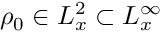Convert formula to latex. <formula><loc_0><loc_0><loc_500><loc_500>\rho _ { 0 } \in L _ { x } ^ { 2 } \subset L _ { x } ^ { \infty }</formula> 